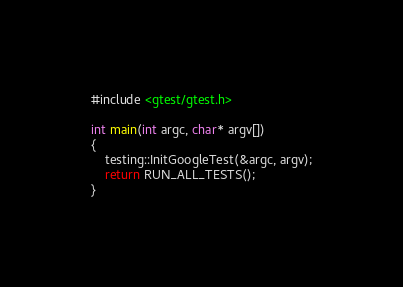Convert code to text. <code><loc_0><loc_0><loc_500><loc_500><_C++_>
#include <gtest/gtest.h>

int main(int argc, char* argv[])
{
    testing::InitGoogleTest(&argc, argv);
    return RUN_ALL_TESTS();
}</code> 